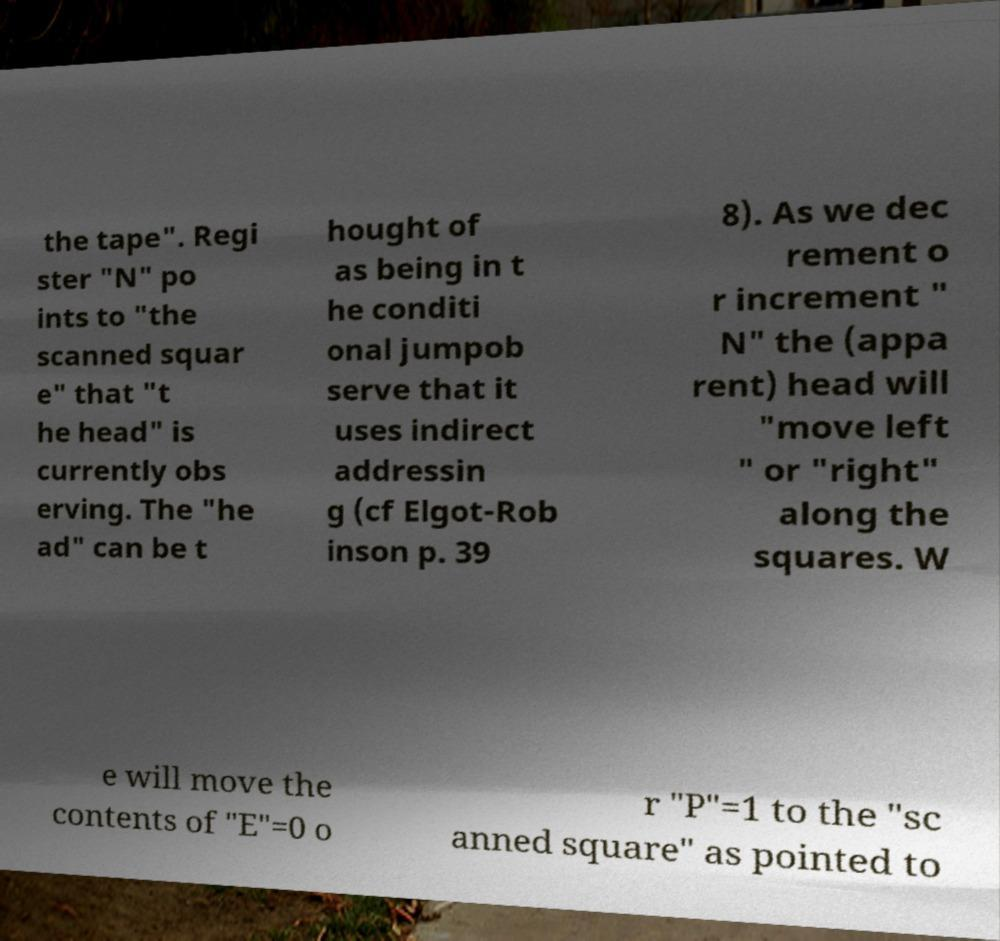Can you read and provide the text displayed in the image?This photo seems to have some interesting text. Can you extract and type it out for me? the tape". Regi ster "N" po ints to "the scanned squar e" that "t he head" is currently obs erving. The "he ad" can be t hought of as being in t he conditi onal jumpob serve that it uses indirect addressin g (cf Elgot-Rob inson p. 39 8). As we dec rement o r increment " N" the (appa rent) head will "move left " or "right" along the squares. W e will move the contents of "E"=0 o r "P"=1 to the "sc anned square" as pointed to 